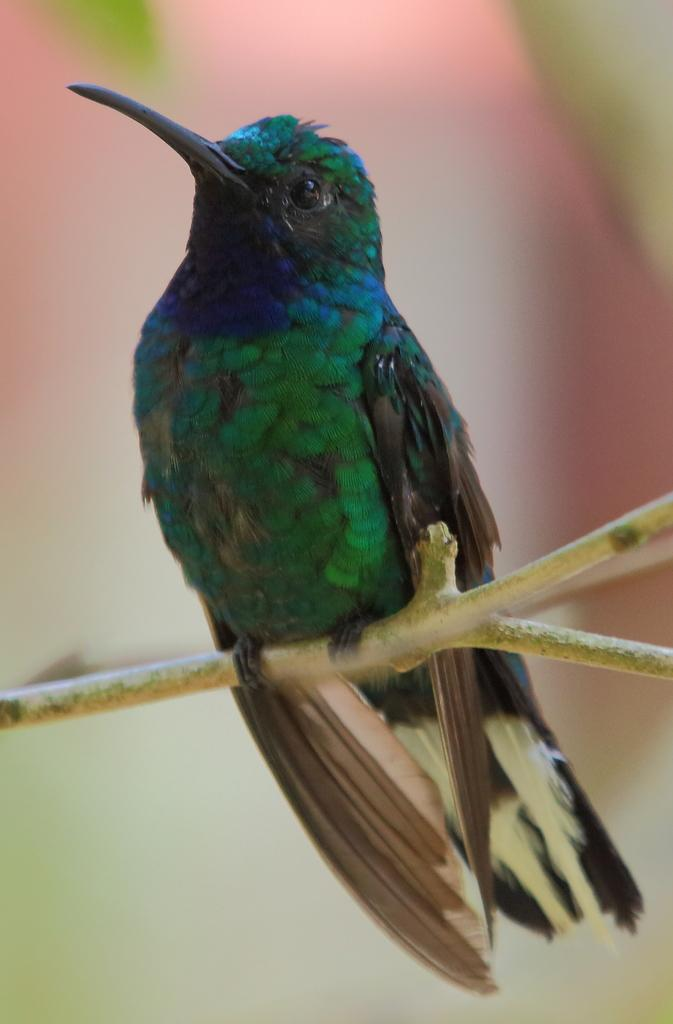What type of animal can be seen in the image? There is a bird in the image. Where is the bird located? The bird is on a branch. Can you describe the background of the image? The background of the image is blurry. What color paint is the bird using to write a note in the image? There is no paint or note present in the image; it features a bird on a branch with a blurry background. 